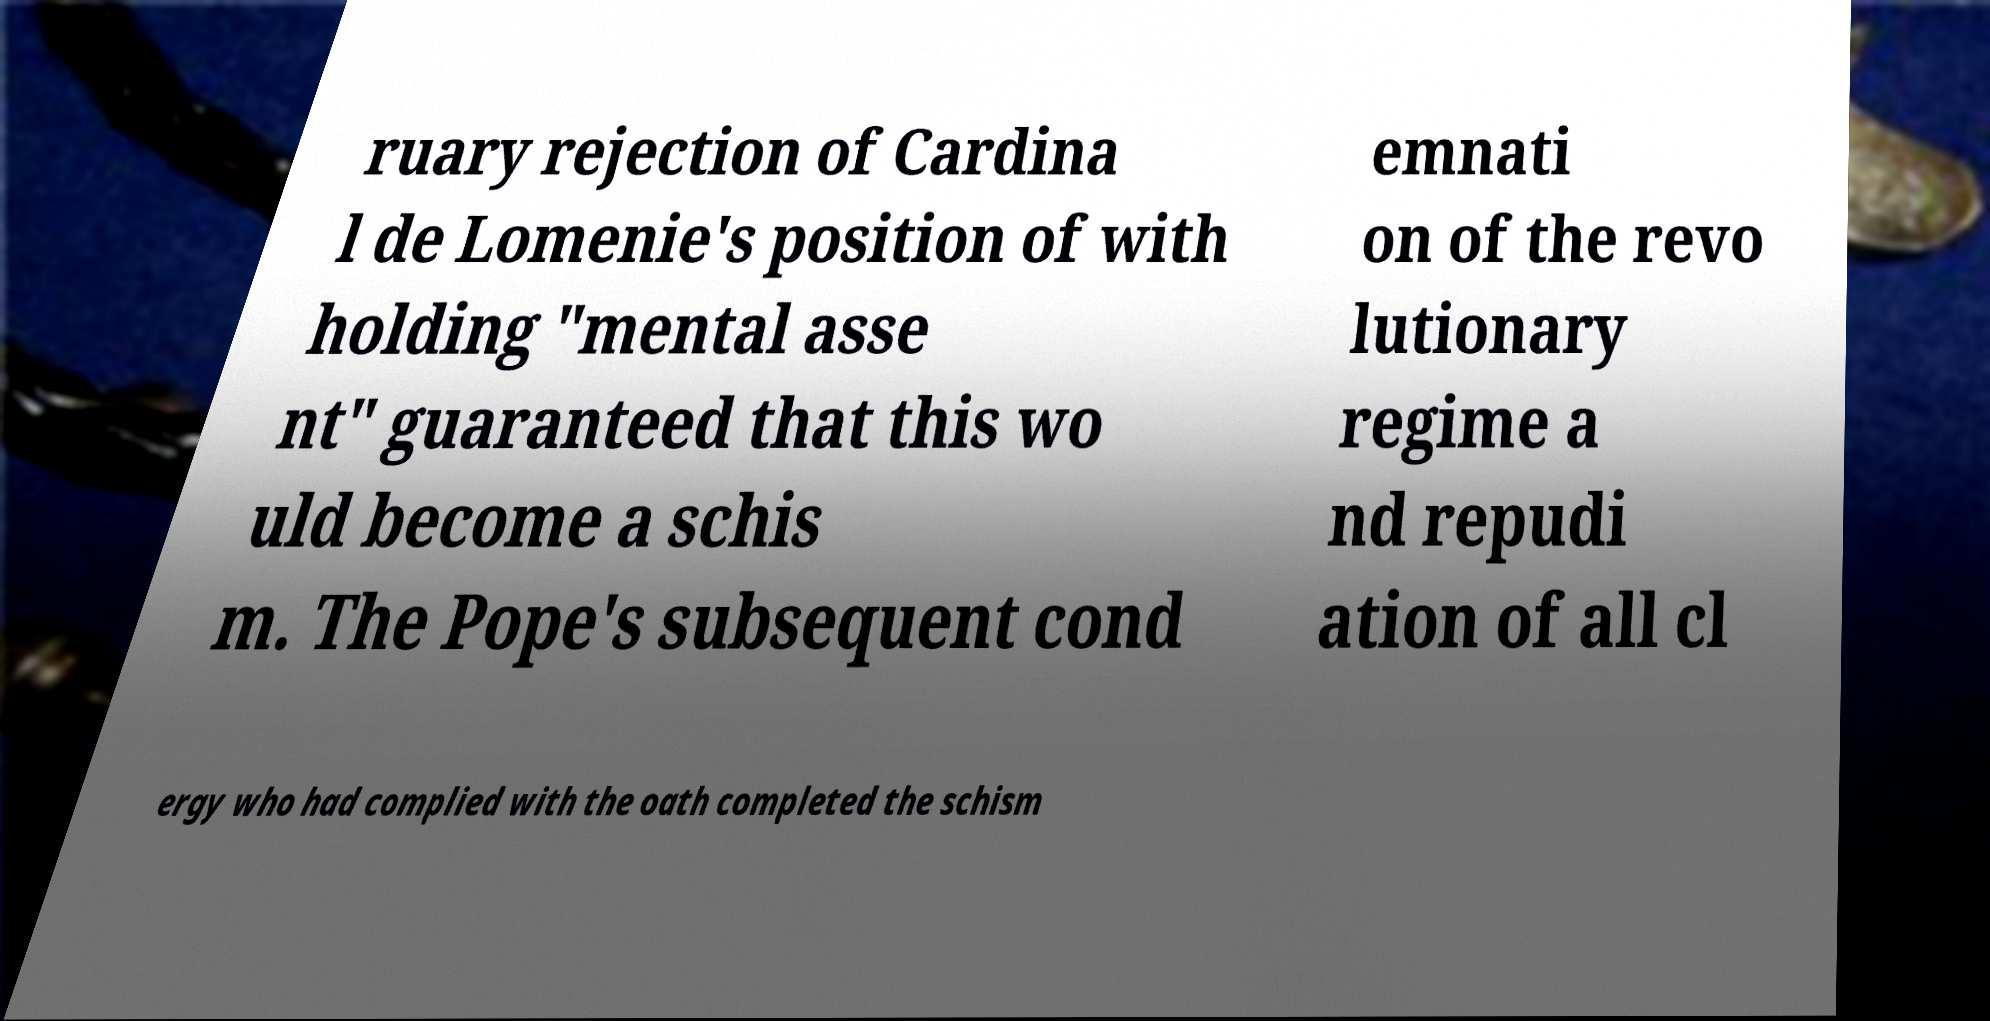Can you read and provide the text displayed in the image?This photo seems to have some interesting text. Can you extract and type it out for me? ruary rejection of Cardina l de Lomenie's position of with holding "mental asse nt" guaranteed that this wo uld become a schis m. The Pope's subsequent cond emnati on of the revo lutionary regime a nd repudi ation of all cl ergy who had complied with the oath completed the schism 